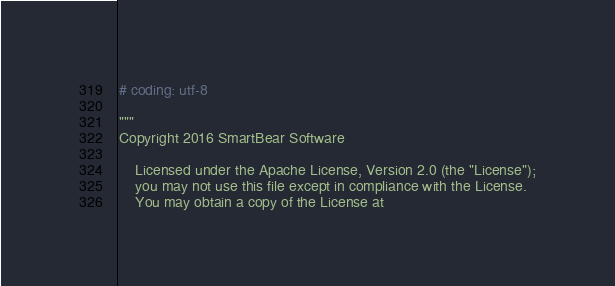Convert code to text. <code><loc_0><loc_0><loc_500><loc_500><_Python_># coding: utf-8

"""
Copyright 2016 SmartBear Software

    Licensed under the Apache License, Version 2.0 (the "License");
    you may not use this file except in compliance with the License.
    You may obtain a copy of the License at
</code> 